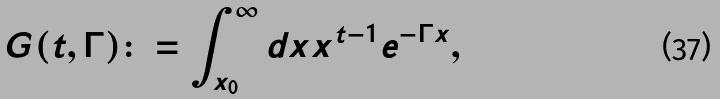<formula> <loc_0><loc_0><loc_500><loc_500>G ( t , \Gamma ) \colon = \int ^ { \infty } _ { x _ { 0 } } d x x ^ { t - 1 } e ^ { - \Gamma x } ,</formula> 